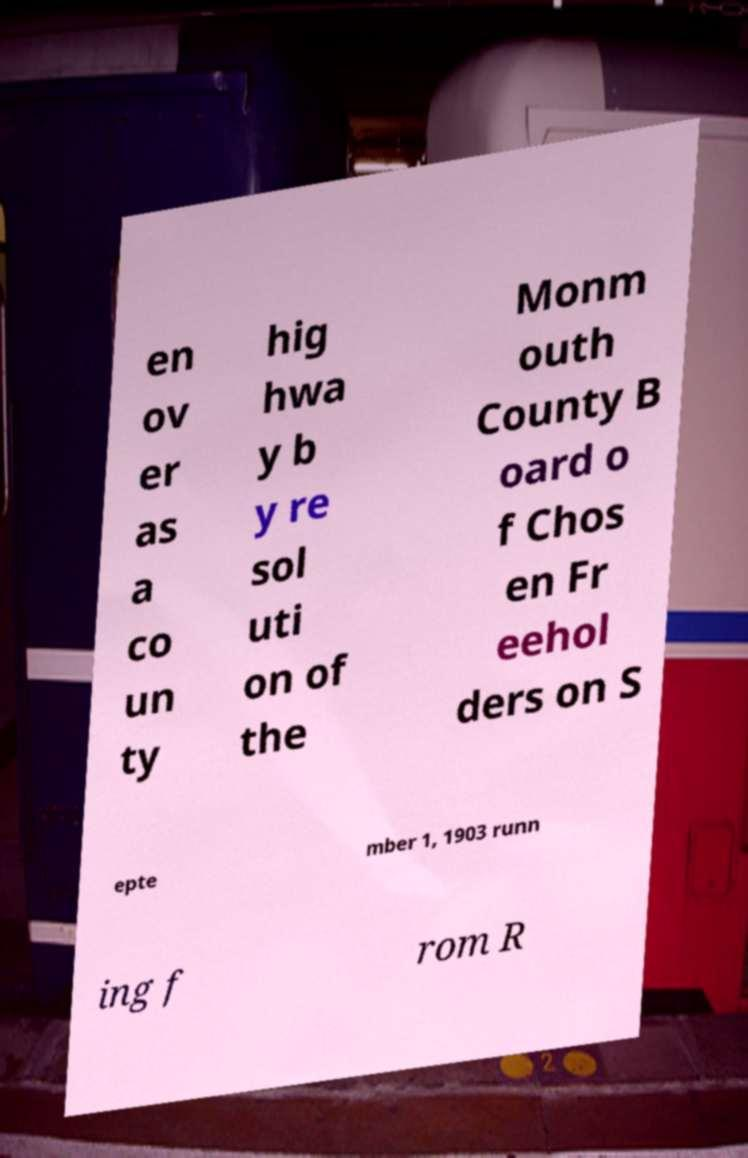For documentation purposes, I need the text within this image transcribed. Could you provide that? en ov er as a co un ty hig hwa y b y re sol uti on of the Monm outh County B oard o f Chos en Fr eehol ders on S epte mber 1, 1903 runn ing f rom R 